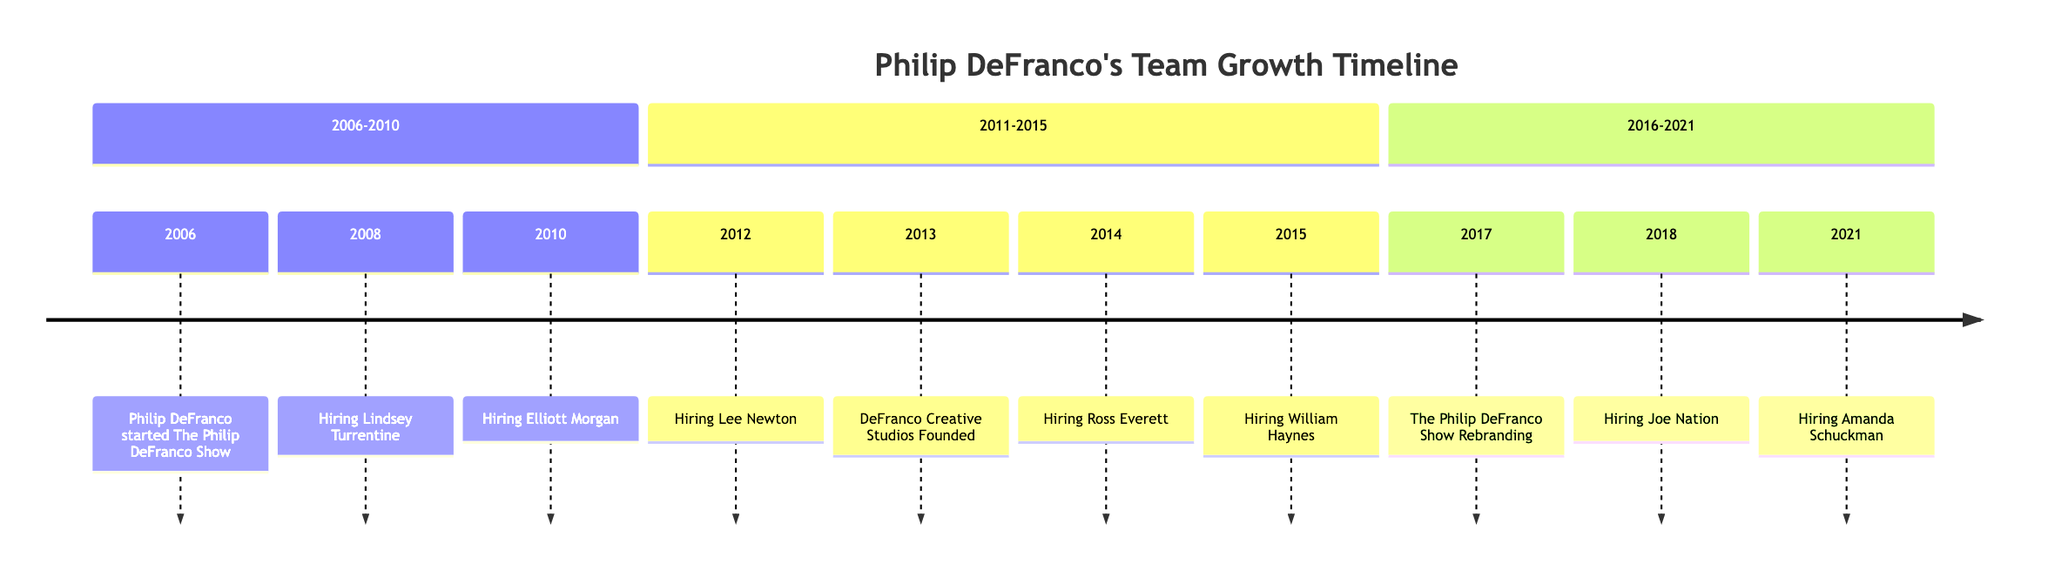What year did Philip DeFranco start his show? The timeline starts with the year 2006 indicating when Philip DeFranco began The Philip DeFranco Show.
Answer: 2006 Who was hired as a production assistant in 2008? The timeline lists "Hiring Lindsey Turrentine" in 2008, indicating she was the production assistant hired that year.
Answer: Lindsey Turrentine How many team members were hired between 2010 and 2015? The years 2010 to 2015 include three events of hiring: Elliott Morgan (2010), Ross Everett (2014), and William Haynes (2015), totaling three hires.
Answer: 3 What significant event happened in 2013? The timeline highlights "DeFranco Creative Studios Founded" as the key event for 2013, marking a significant milestone in the timeline.
Answer: DeFranco Creative Studios Founded Which member was hired as a director and producer in 2018? The timeline specifies "Hiring Joe Nation" in 2018, indicating he was the director and producer hired that year.
Answer: Joe Nation What was the nature of the team rebranding in 2017? In 2017, the event noted is "The Philip DeFranco Show Rebranding", which involved studio upgrades and additional editorial staff as part of the rebranding process.
Answer: The Philip DeFranco Show Rebranding How many years passed between the hiring of Lindsey Turrentine and Amanda Schuckman? Lindsey Turrentine was hired in 2008 and Amanda Schuckman in 2021; counting the years in between gives 13 years.
Answer: 13 Which year saw the hiring of a female team member for the first time? The timeline shows that Lee Newton was hired in 2012, indicating the first hiring of a female team member.
Answer: 2012 What year was the last hiring event listed on the timeline? The timeline ends with the hiring of Amanda Schuckman in 2021, marking the last event represented.
Answer: 2021 